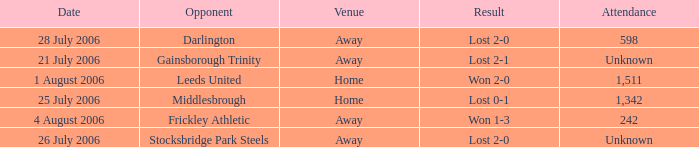Which opponent has unknown attendance, and lost 2-0? Stocksbridge Park Steels. Write the full table. {'header': ['Date', 'Opponent', 'Venue', 'Result', 'Attendance'], 'rows': [['28 July 2006', 'Darlington', 'Away', 'Lost 2-0', '598'], ['21 July 2006', 'Gainsborough Trinity', 'Away', 'Lost 2-1', 'Unknown'], ['1 August 2006', 'Leeds United', 'Home', 'Won 2-0', '1,511'], ['25 July 2006', 'Middlesbrough', 'Home', 'Lost 0-1', '1,342'], ['4 August 2006', 'Frickley Athletic', 'Away', 'Won 1-3', '242'], ['26 July 2006', 'Stocksbridge Park Steels', 'Away', 'Lost 2-0', 'Unknown']]} 